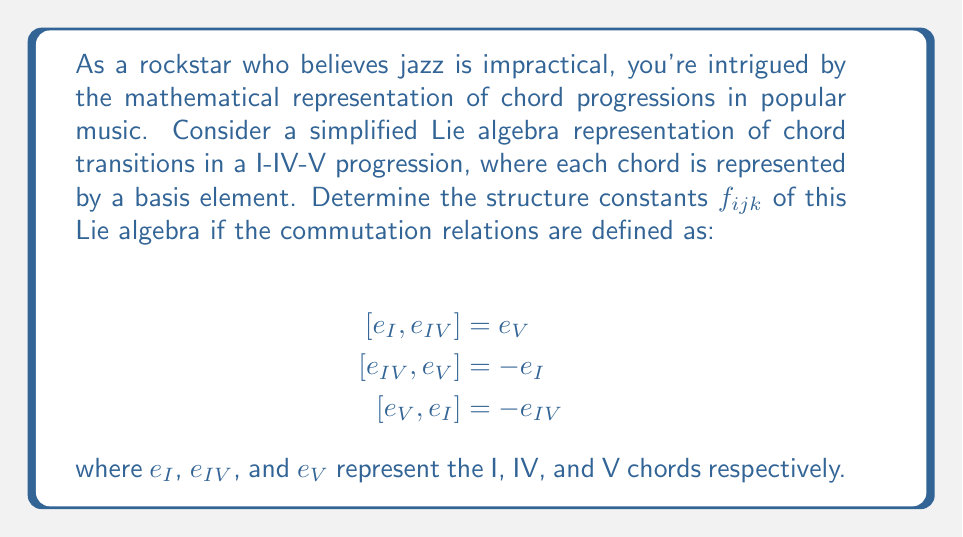Help me with this question. To determine the structure constants of this Lie algebra, we need to express the commutation relations in terms of the structure constants $f_{ijk}$. The general form of a commutation relation in a Lie algebra is:

$$[e_i, e_j] = \sum_k f_{ijk} e_k$$

where $f_{ijk}$ are the structure constants.

Let's analyze each commutation relation:

1. $[e_I, e_{IV}] = e_V$
   This implies $f_{I,IV,V} = 1$ and all other $f_{I,IV,k} = 0$

2. $[e_{IV}, e_V] = -e_I$
   This implies $f_{IV,V,I} = -1$ and all other $f_{IV,V,k} = 0$

3. $[e_V, e_I] = -e_{IV}$
   This implies $f_{V,I,IV} = -1$ and all other $f_{V,I,k} = 0$

Note that the structure constants are antisymmetric in the first two indices:
$$f_{ijk} = -f_{jik}$$

This means we also have:
$f_{IV,I,V} = -1$
$f_{V,IV,I} = 1$
$f_{I,V,IV} = 1$

All other structure constants are zero.

We can represent the non-zero structure constants in a 3x3x3 array:

$$f_{ijk} = \begin{cases}
1 & \text{if } (i,j,k) \text{ is a cyclic permutation of } (I,IV,V) \\
-1 & \text{if } (i,j,k) \text{ is an anti-cyclic permutation of } (I,IV,V) \\
0 & \text{otherwise}
\end{cases}$$

This Lie algebra is isomorphic to $\mathfrak{so}(3)$, the Lie algebra of 3D rotations, which is fitting for the cyclical nature of the I-IV-V progression in popular music.
Answer: The non-zero structure constants are:
$$f_{I,IV,V} = f_{IV,V,I} = f_{V,I,IV} = 1$$
$$f_{IV,I,V} = f_{V,IV,I} = f_{I,V,IV} = -1$$
All other $f_{ijk} = 0$ 